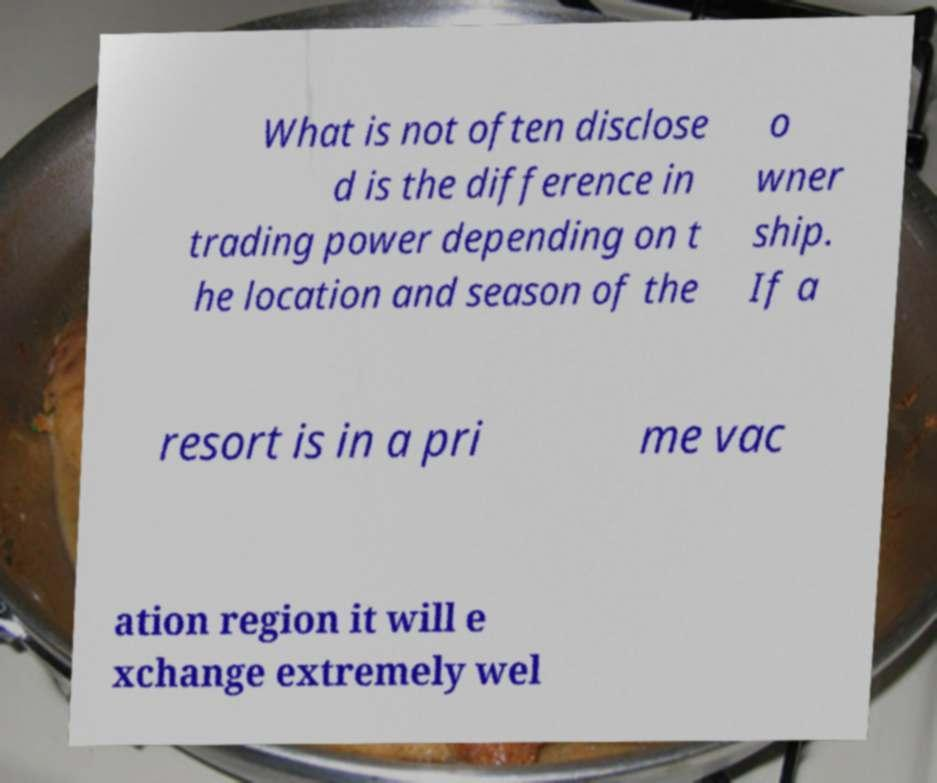Could you extract and type out the text from this image? What is not often disclose d is the difference in trading power depending on t he location and season of the o wner ship. If a resort is in a pri me vac ation region it will e xchange extremely wel 